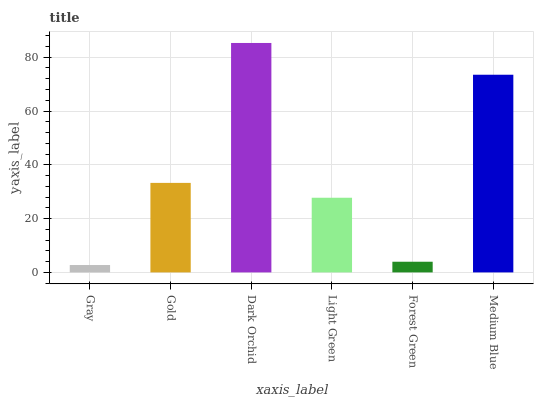Is Gold the minimum?
Answer yes or no. No. Is Gold the maximum?
Answer yes or no. No. Is Gold greater than Gray?
Answer yes or no. Yes. Is Gray less than Gold?
Answer yes or no. Yes. Is Gray greater than Gold?
Answer yes or no. No. Is Gold less than Gray?
Answer yes or no. No. Is Gold the high median?
Answer yes or no. Yes. Is Light Green the low median?
Answer yes or no. Yes. Is Gray the high median?
Answer yes or no. No. Is Dark Orchid the low median?
Answer yes or no. No. 